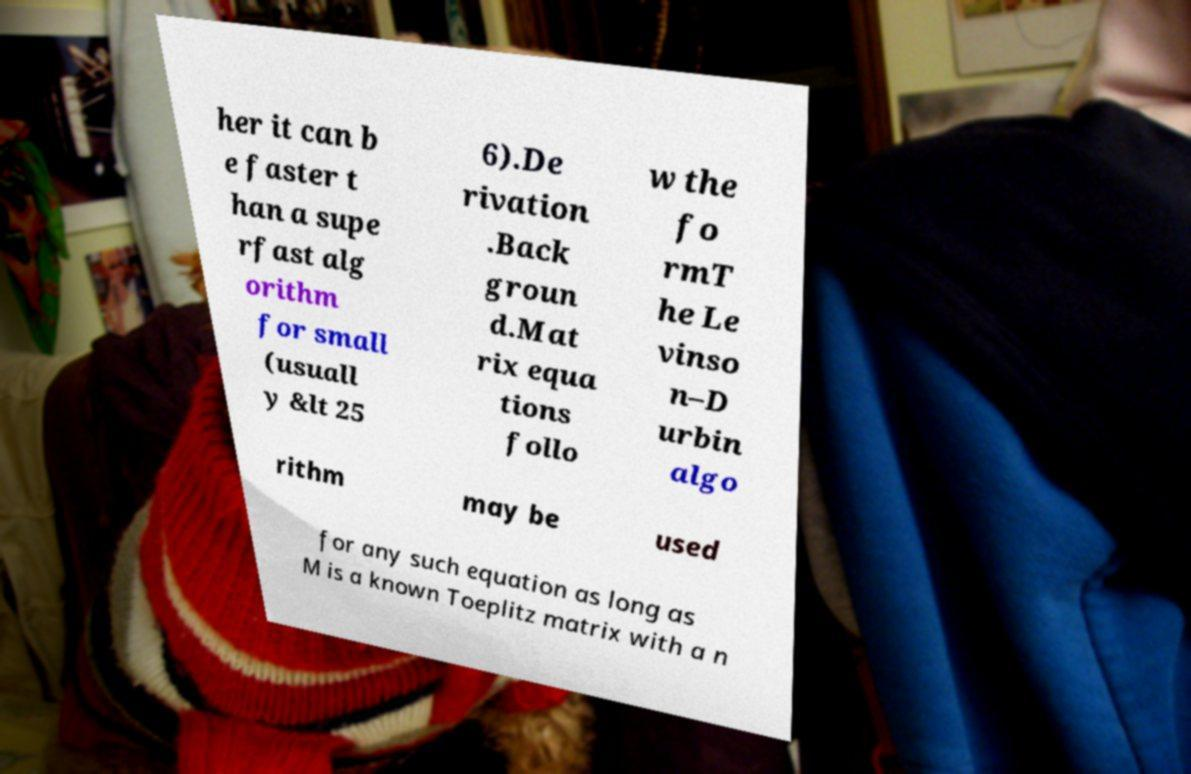For documentation purposes, I need the text within this image transcribed. Could you provide that? her it can b e faster t han a supe rfast alg orithm for small (usuall y &lt 25 6).De rivation .Back groun d.Mat rix equa tions follo w the fo rmT he Le vinso n–D urbin algo rithm may be used for any such equation as long as M is a known Toeplitz matrix with a n 